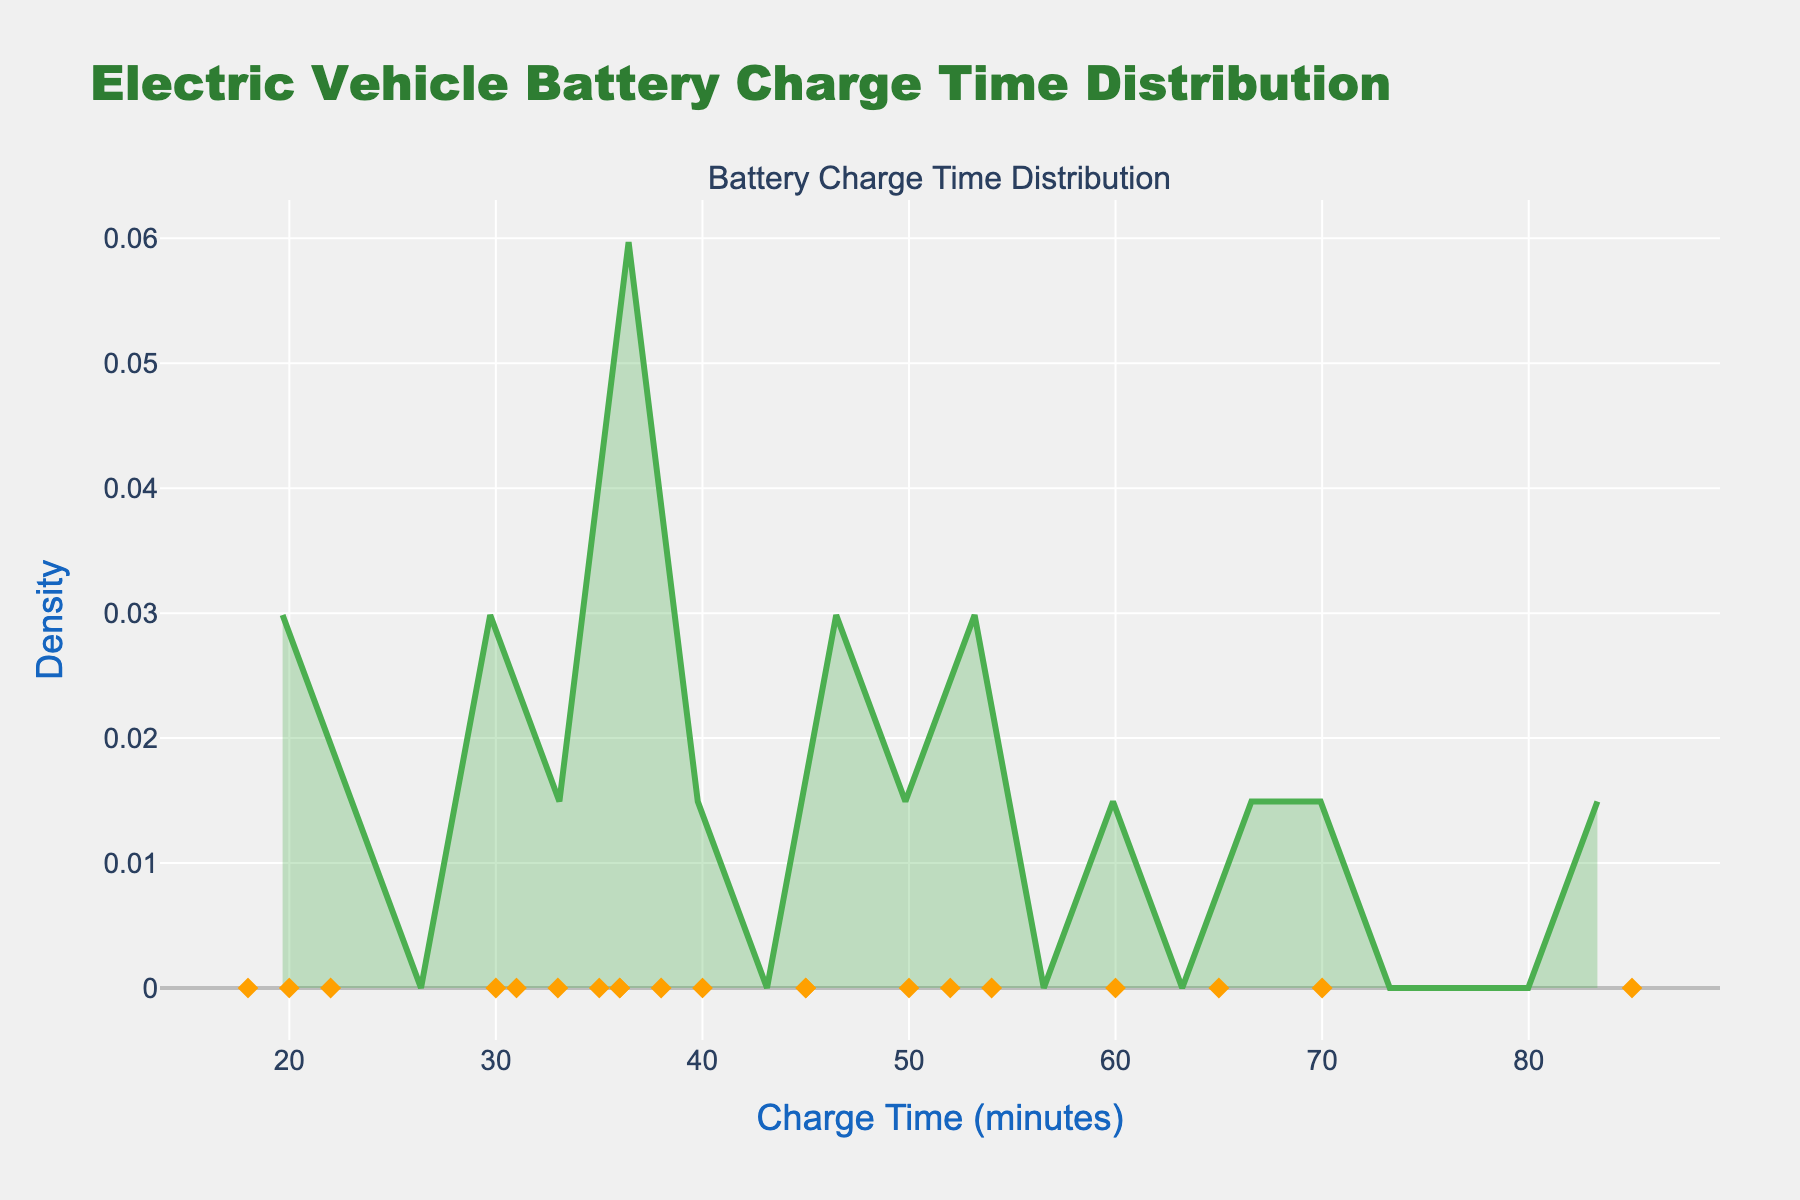What's the title of the figure? The title is displayed prominently at the top of the figure and provides an overall description of the plot.
Answer: Electric Vehicle Battery Charge Time Distribution What is the range of the Charge Time axis? The Charge Time axis, which is the x-axis of the plot, starts from around 0 and goes up to approximately 100 minutes.
Answer: 0 to 100 minutes What color is used to fill the density plot? The density plot is filled with a semi-transparent green color, which is described as 'rgba(76, 175, 80, 0.3)'.
Answer: Green (semi-transparent) How many individual data points are plotted? Each electric vehicle model's charge time is represented by a marker on the plot. By counting the markers, we can determine the number of data points.
Answer: 20 Which vehicle model has the highest charge time? By looking at the scatter plot where individual points are located along the Charge Time axis, the model with the highest value is determined.
Answer: Jaguar I-PACE Which vehicle model has the second smallest charge time? By observing the scatter points along the x-axis (Charge Time), we identify the smallest and the second smallest values. The second smallest charge time belongs to the respective vehicle model.
Answer: Lucid Air What is the approximate density value at 50 minutes on the Charge Time axis? Locate the 50-minute mark on the x-axis and check the corresponding density value on the y-axis of the density plot.
Answer: Around 0.06 What is the spread of charge times for most of the vehicles? By examining the main concentration of data points in the density plot, we can describe the spread where most vehicles' charge times fall.
Answer: 30 to 60 minutes Which vehicle models have a charge time greater than 60 minutes? Observe the scatter points on the right side of the 60-minute mark on the x-axis to identify the models.
Answer: Jaguar I-PACE, Rivian R1T, Chevrolet Bolt Which vehicle models show the lowest density region on the plot? Identify the regions on the plot where the density curve dips the lowest and note the vehicles in those areas.
Answer: Porsche Taycan, Kia EV6, Lucid Air 